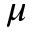Convert formula to latex. <formula><loc_0><loc_0><loc_500><loc_500>\mu</formula> 